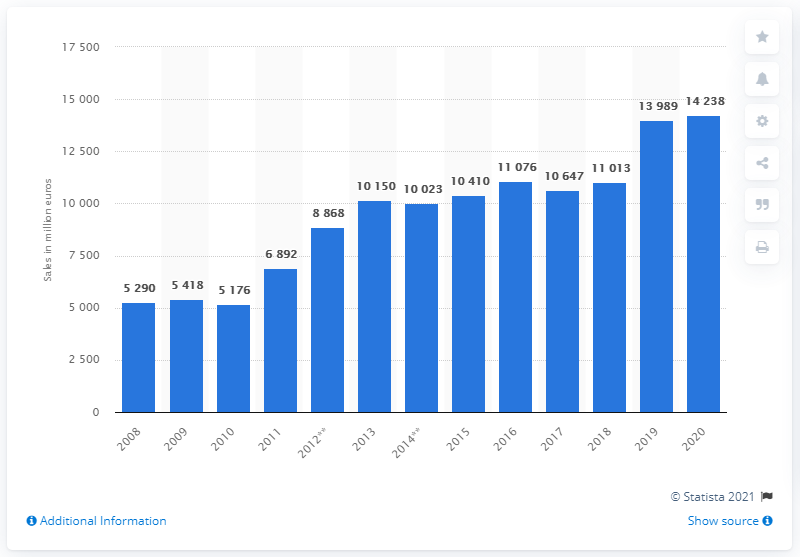Highlight a few significant elements in this photo. In the fiscal year 2020, the total sales of the Richemont Group worldwide were 14,238. 